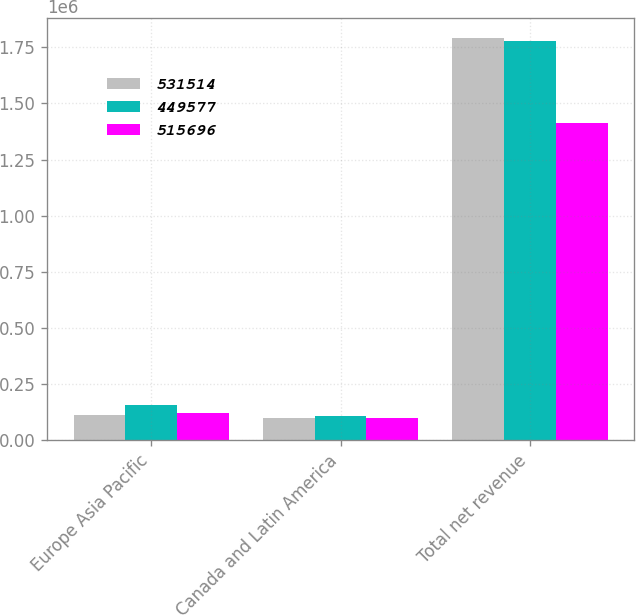Convert chart. <chart><loc_0><loc_0><loc_500><loc_500><stacked_bar_chart><ecel><fcel>Europe Asia Pacific<fcel>Canada and Latin America<fcel>Total net revenue<nl><fcel>531514<fcel>111223<fcel>97842<fcel>1.79289e+06<nl><fcel>449577<fcel>157183<fcel>107741<fcel>1.77975e+06<nl><fcel>515696<fcel>120629<fcel>100529<fcel>1.4137e+06<nl></chart> 